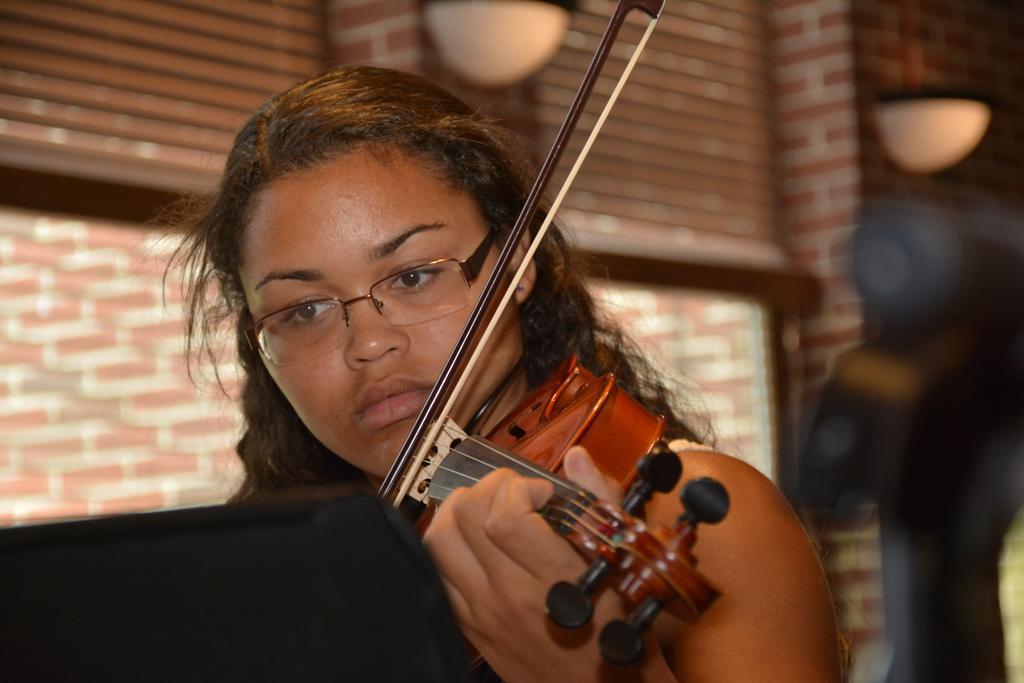Could you give a brief overview of what you see in this image? In the center of the image there is a lady, she is playing a violin. In the background there is a window and a brick wall. 